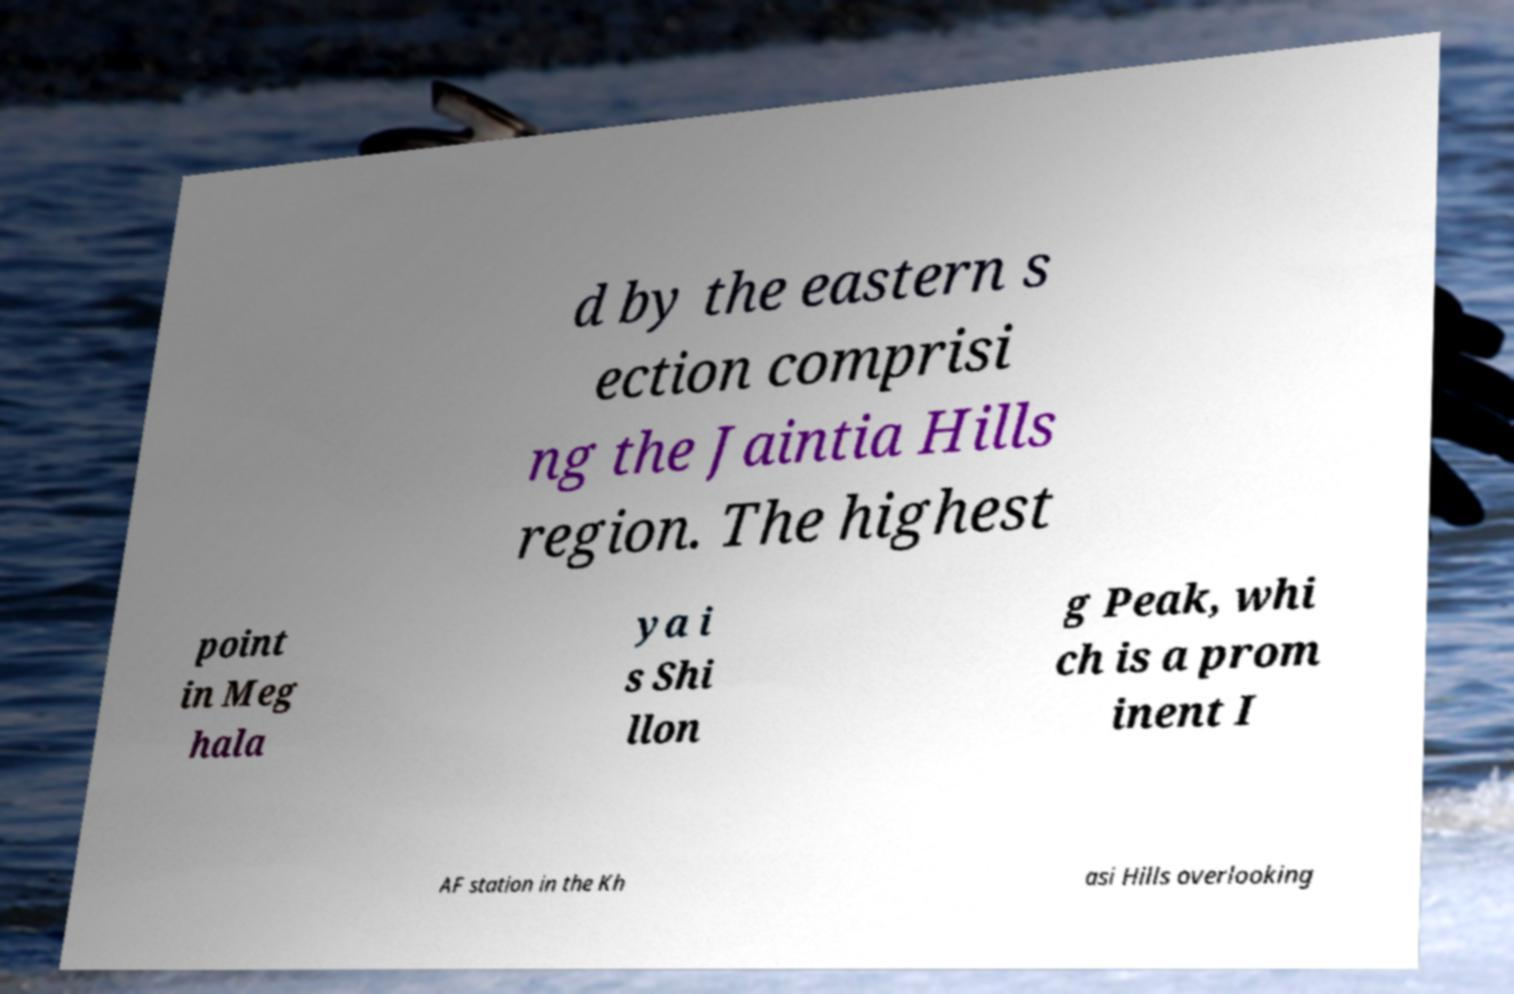Can you read and provide the text displayed in the image?This photo seems to have some interesting text. Can you extract and type it out for me? d by the eastern s ection comprisi ng the Jaintia Hills region. The highest point in Meg hala ya i s Shi llon g Peak, whi ch is a prom inent I AF station in the Kh asi Hills overlooking 